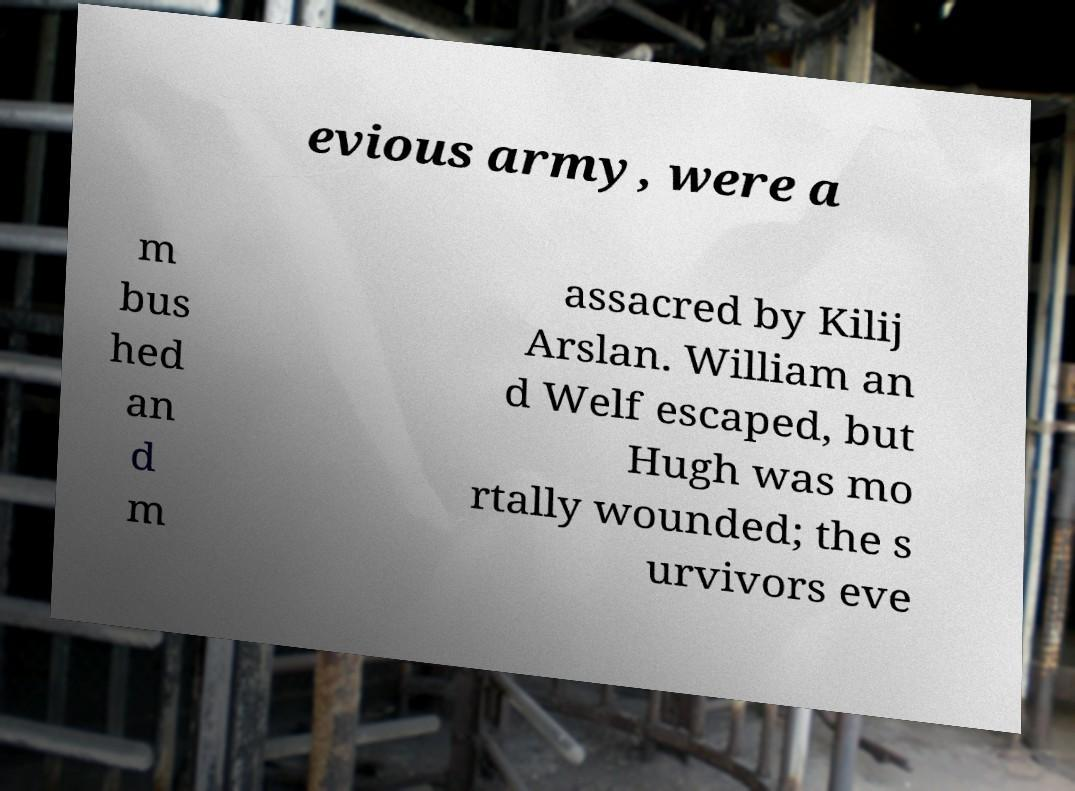Please identify and transcribe the text found in this image. evious army, were a m bus hed an d m assacred by Kilij Arslan. William an d Welf escaped, but Hugh was mo rtally wounded; the s urvivors eve 